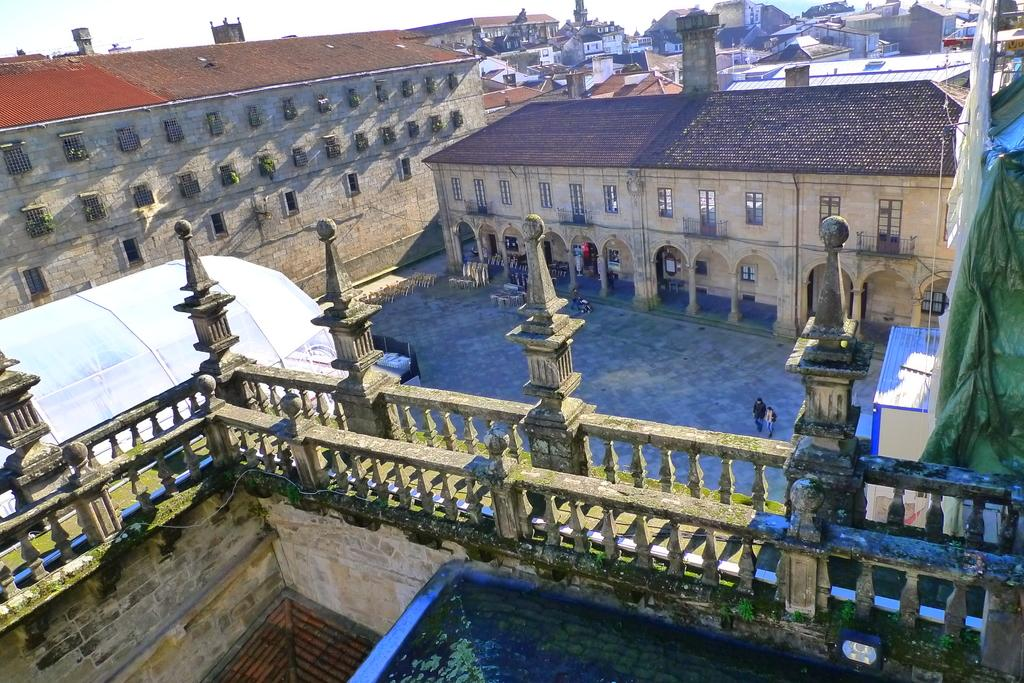How many people are present in the image? There are two people on the ground in the image. What type of structures can be seen in the image? There are fences, sheds, and buildings with windows in the image. What other objects are visible in the image? There are some objects in the image. What can be seen in the background of the image? The sky is visible in the background of the image. What type of waste can be seen in the image? There is no waste visible in the image. Is there a mine present in the image? There is no mine present in the image. 